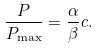Convert formula to latex. <formula><loc_0><loc_0><loc_500><loc_500>\frac { P } { P _ { \max } } = \frac { \alpha } { \beta } c .</formula> 